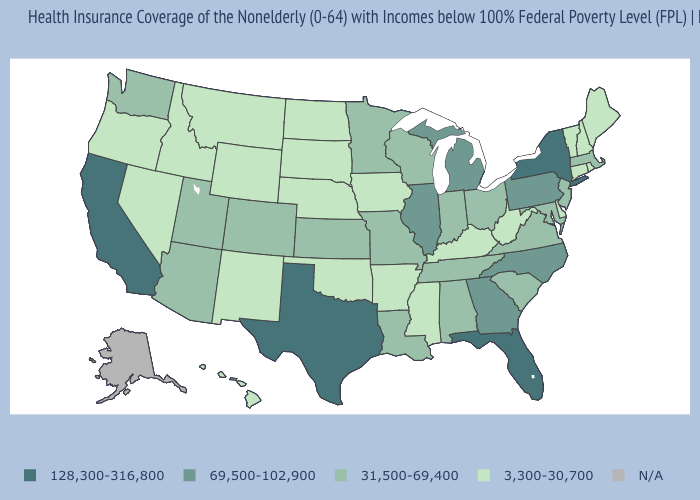What is the value of Tennessee?
Answer briefly. 31,500-69,400. What is the highest value in the USA?
Give a very brief answer. 128,300-316,800. Among the states that border Virginia , which have the highest value?
Quick response, please. North Carolina. What is the value of Virginia?
Short answer required. 31,500-69,400. Which states have the lowest value in the Northeast?
Be succinct. Connecticut, Maine, New Hampshire, Rhode Island, Vermont. What is the lowest value in states that border Indiana?
Concise answer only. 3,300-30,700. Which states have the lowest value in the USA?
Be succinct. Arkansas, Connecticut, Delaware, Hawaii, Idaho, Iowa, Kentucky, Maine, Mississippi, Montana, Nebraska, Nevada, New Hampshire, New Mexico, North Dakota, Oklahoma, Oregon, Rhode Island, South Dakota, Vermont, West Virginia, Wyoming. What is the value of West Virginia?
Keep it brief. 3,300-30,700. Does California have the highest value in the USA?
Be succinct. Yes. Among the states that border Arizona , does California have the highest value?
Quick response, please. Yes. Name the states that have a value in the range 31,500-69,400?
Quick response, please. Alabama, Arizona, Colorado, Indiana, Kansas, Louisiana, Maryland, Massachusetts, Minnesota, Missouri, New Jersey, Ohio, South Carolina, Tennessee, Utah, Virginia, Washington, Wisconsin. Name the states that have a value in the range 69,500-102,900?
Short answer required. Georgia, Illinois, Michigan, North Carolina, Pennsylvania. Name the states that have a value in the range 69,500-102,900?
Concise answer only. Georgia, Illinois, Michigan, North Carolina, Pennsylvania. Among the states that border Oregon , which have the lowest value?
Write a very short answer. Idaho, Nevada. 